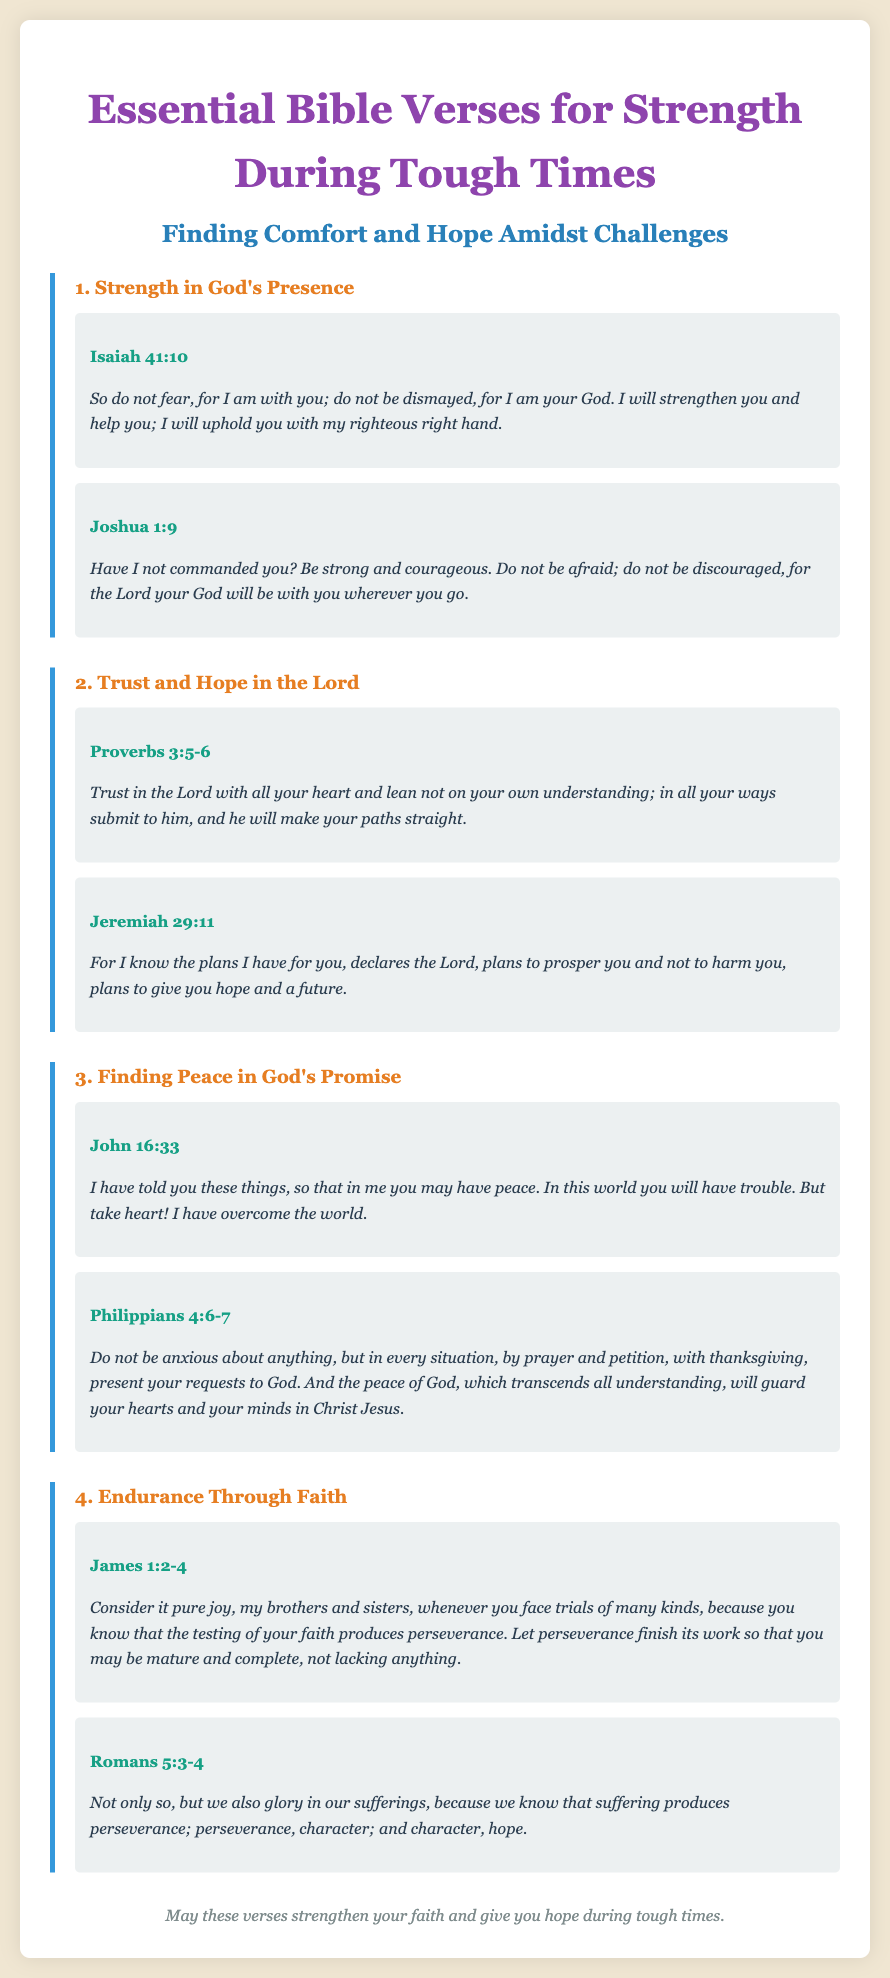What is the title of the document? The title is stated prominently at the top of the document, "Essential Bible Verses for Strength During Tough Times".
Answer: Essential Bible Verses for Strength During Tough Times Which verse comes from Isaiah? Isaiah 41:10 is included in the section about Strength in God's Presence as one of the key verses.
Answer: Isaiah 41:10 How many sections are there in total? The document contains a total of four sections, each focusing on different aspects of faith and strength.
Answer: 4 What is the main theme of the verses in the first section? The first section focuses on God's presence and strength during challenging times, emphasizing that He will support us.
Answer: Strength in God's Presence According to Philippians 4:6-7, what should we do in every situation? The verse encourages presenting our requests to God through prayer and petition, which helps us find peace.
Answer: Present your requests to God What emotion should be considered during trials, according to James 1:2-4? James instructs us to consider it pure joy when facing trials, as it helps with perseverance and growth in faith.
Answer: Pure joy What does Romans 5:3-4 state suffering produces? The verse explains that suffering leads to perseverance, character, and ultimately hope, highlighting the transformative journey of faith.
Answer: Perseverance, character, hope What is the color used for the heading "Strength in God's Presence"? The heading for this section is highlighted in orange to distinguish it from the other headings in the document.
Answer: Orange 